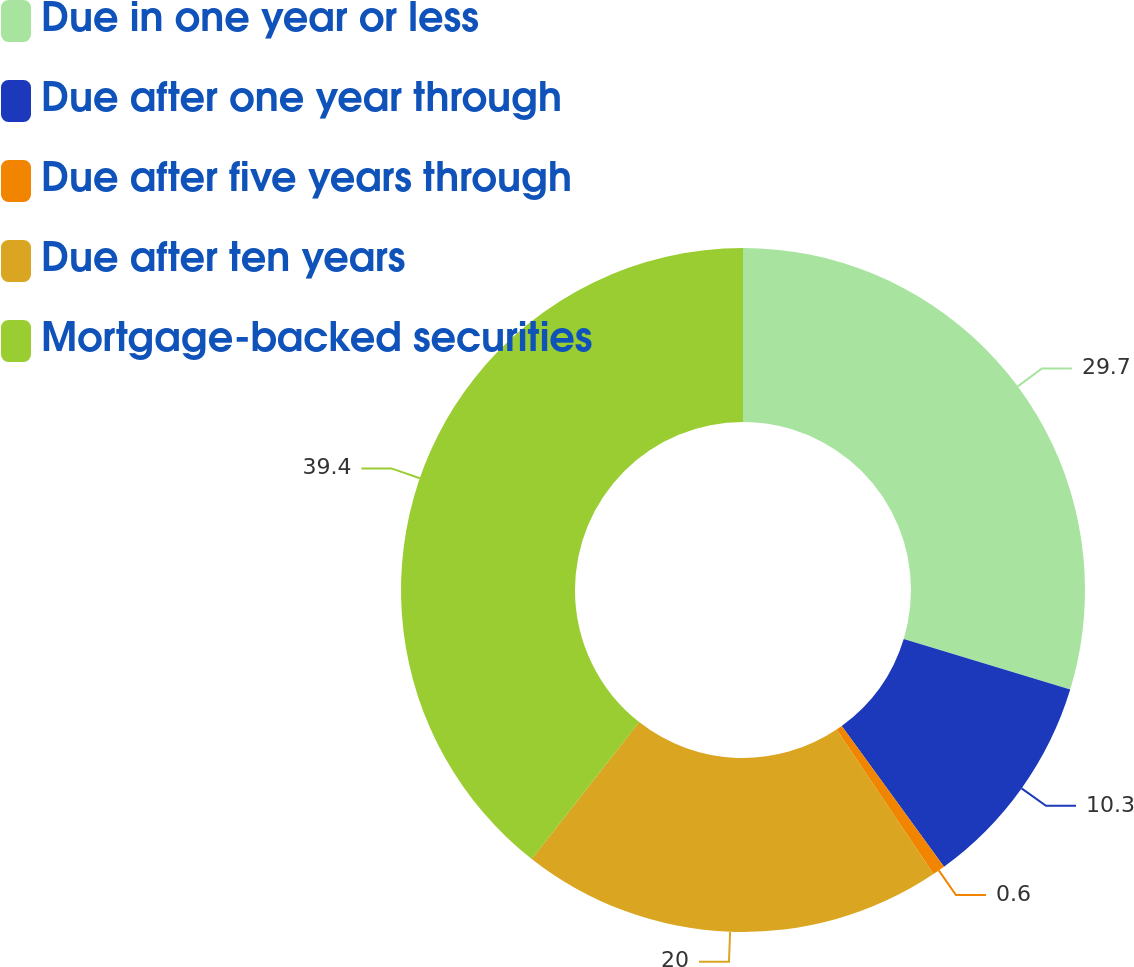Convert chart. <chart><loc_0><loc_0><loc_500><loc_500><pie_chart><fcel>Due in one year or less<fcel>Due after one year through<fcel>Due after five years through<fcel>Due after ten years<fcel>Mortgage-backed securities<nl><fcel>29.7%<fcel>10.3%<fcel>0.6%<fcel>20.0%<fcel>39.4%<nl></chart> 